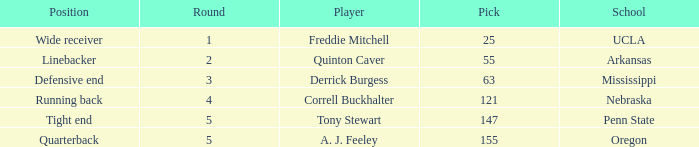What position did a. j. feeley play who was picked in round 5? Quarterback. 